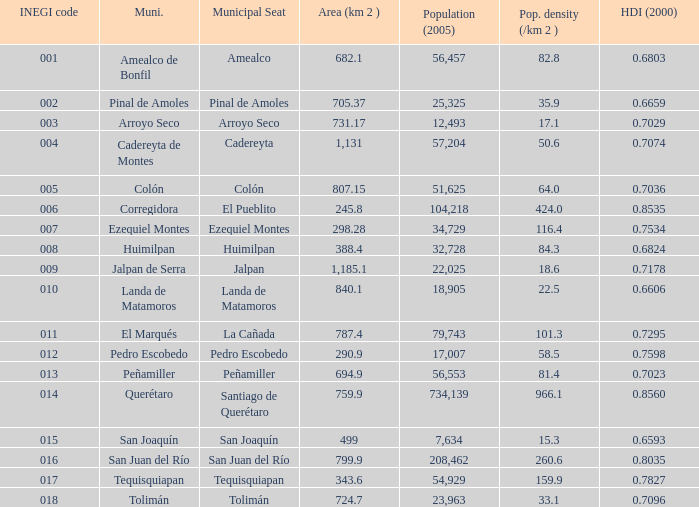WHat is the amount of Human Development Index (2000) that has a Population (2005) of 54,929, and an Area (km 2 ) larger than 343.6? 0.0. 